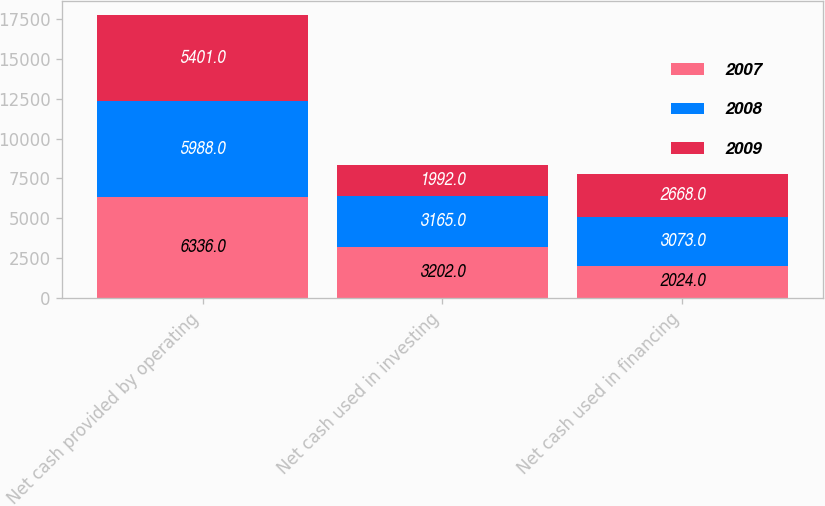Convert chart. <chart><loc_0><loc_0><loc_500><loc_500><stacked_bar_chart><ecel><fcel>Net cash provided by operating<fcel>Net cash used in investing<fcel>Net cash used in financing<nl><fcel>2007<fcel>6336<fcel>3202<fcel>2024<nl><fcel>2008<fcel>5988<fcel>3165<fcel>3073<nl><fcel>2009<fcel>5401<fcel>1992<fcel>2668<nl></chart> 